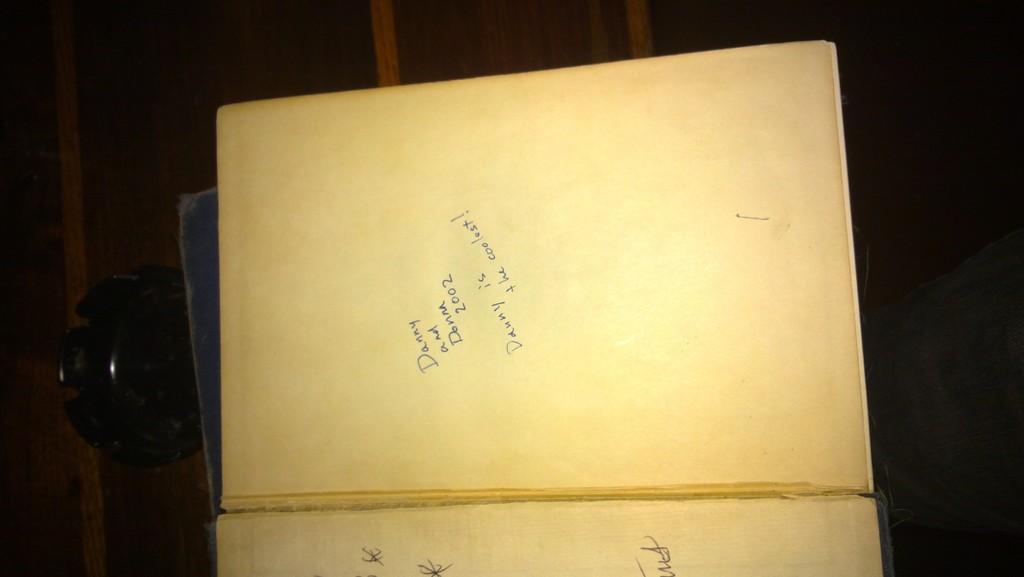What year was the handwritten note written?
Your answer should be compact. 2002. What does the handwriting say?
Your response must be concise. Danny and donna 2002 danny is the coolest!. 